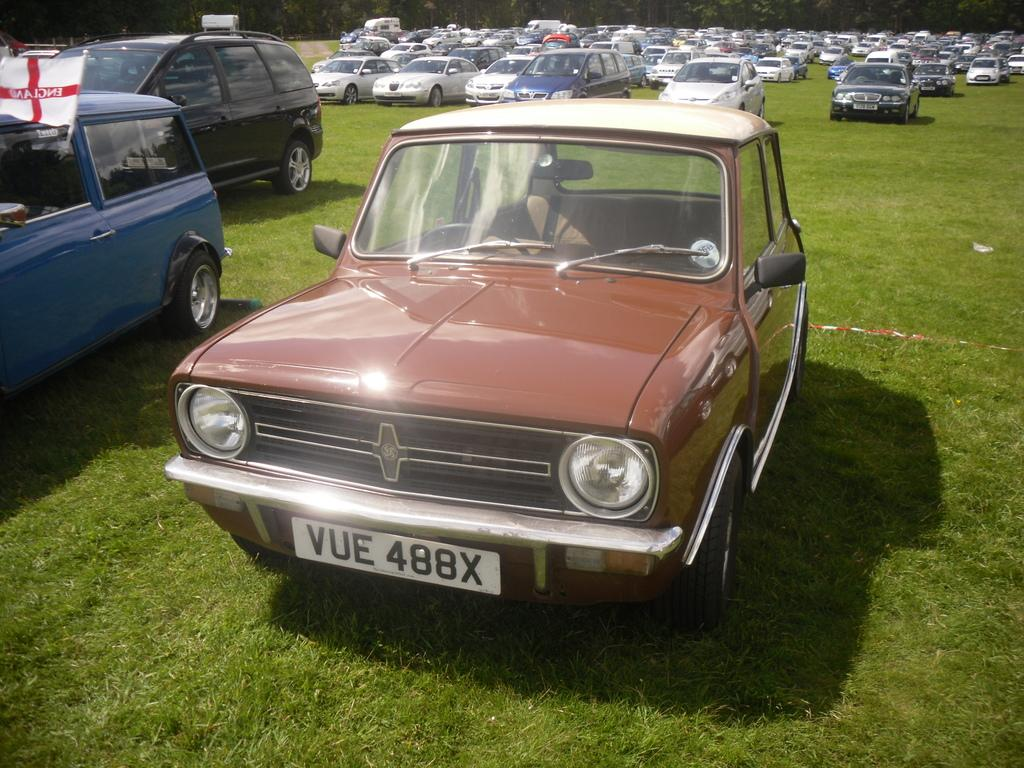What is the location of the vehicles in the image? The vehicles are parked on the grass path in the image. What can be seen in the background of the image? There are trees visible in the background of the image. What type of brake system is installed in the vehicles parked on the grass path? The image does not provide information about the brake systems of the vehicles, so it cannot be determined from the image. 